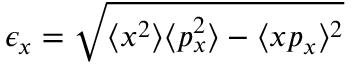<formula> <loc_0><loc_0><loc_500><loc_500>\epsilon _ { x } = \sqrt { \langle x ^ { 2 } \rangle \langle p _ { x } ^ { 2 } \rangle - \langle x p _ { x } \rangle ^ { 2 } }</formula> 